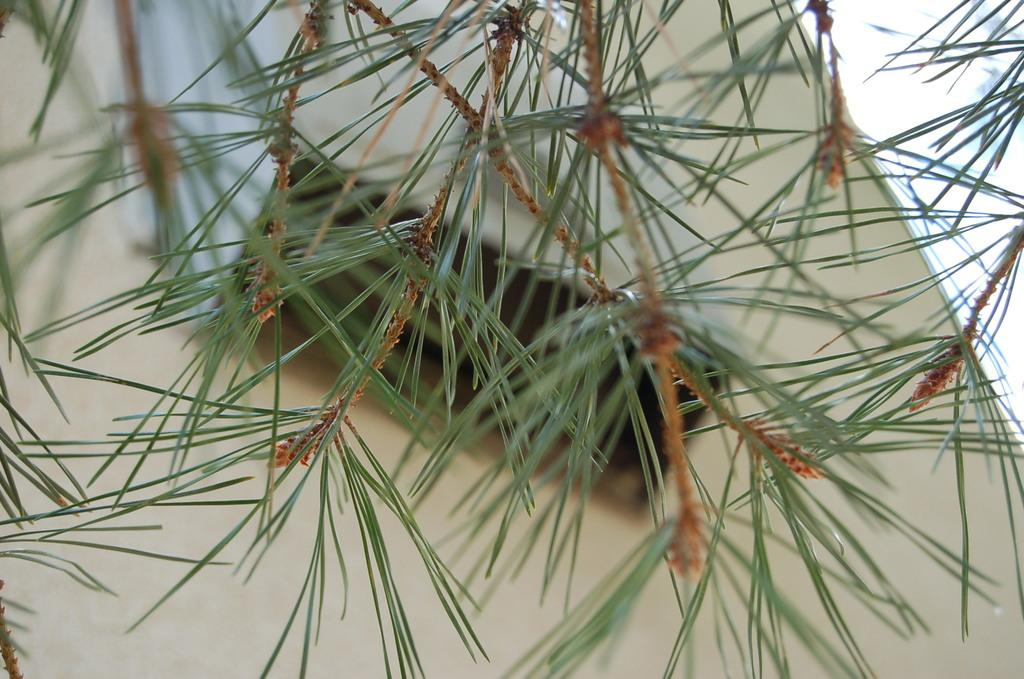What type of plant parts can be seen in the image? There are leaves and stems in the image. Can you describe the object in the background of the image? Unfortunately, the provided facts do not give any information about the object in the background. What type of bell can be heard ringing in the image? There is no bell present in the image, and therefore no sound can be heard. 